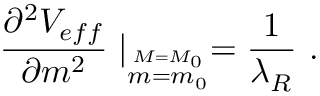Convert formula to latex. <formula><loc_0><loc_0><loc_500><loc_500>{ \frac { \partial ^ { 2 } V _ { e f f } } { \partial m ^ { 2 } } } | _ { \stackrel { M = M _ { 0 } } { m = m _ { 0 } } } = { \frac { 1 } { \lambda _ { R } } } .</formula> 